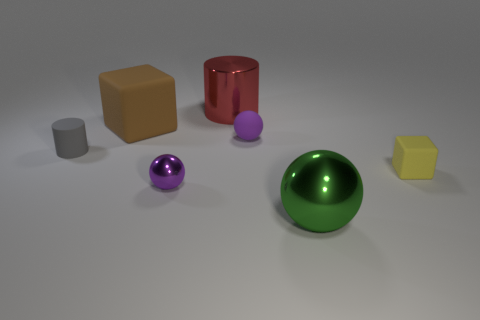Add 3 tiny gray metal blocks. How many objects exist? 10 Subtract all small spheres. How many spheres are left? 1 Subtract all balls. How many objects are left? 4 Subtract 3 spheres. How many spheres are left? 0 Subtract all brown cylinders. Subtract all yellow balls. How many cylinders are left? 2 Subtract all purple cubes. How many yellow balls are left? 0 Subtract all brown matte cubes. Subtract all big brown objects. How many objects are left? 5 Add 7 gray cylinders. How many gray cylinders are left? 8 Add 4 small yellow matte things. How many small yellow matte things exist? 5 Subtract all green spheres. How many spheres are left? 2 